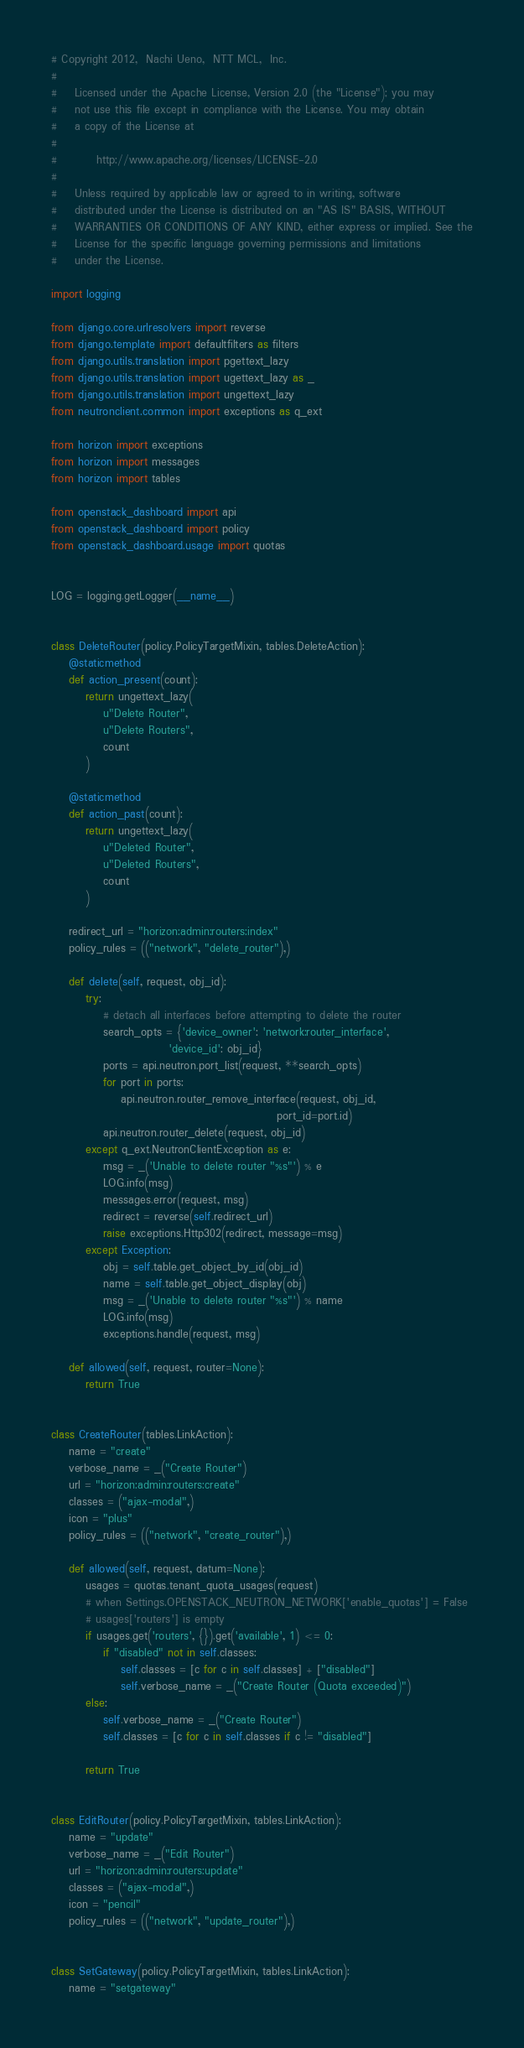<code> <loc_0><loc_0><loc_500><loc_500><_Python_># Copyright 2012,  Nachi Ueno,  NTT MCL,  Inc.
#
#    Licensed under the Apache License, Version 2.0 (the "License"); you may
#    not use this file except in compliance with the License. You may obtain
#    a copy of the License at
#
#         http://www.apache.org/licenses/LICENSE-2.0
#
#    Unless required by applicable law or agreed to in writing, software
#    distributed under the License is distributed on an "AS IS" BASIS, WITHOUT
#    WARRANTIES OR CONDITIONS OF ANY KIND, either express or implied. See the
#    License for the specific language governing permissions and limitations
#    under the License.

import logging

from django.core.urlresolvers import reverse
from django.template import defaultfilters as filters
from django.utils.translation import pgettext_lazy
from django.utils.translation import ugettext_lazy as _
from django.utils.translation import ungettext_lazy
from neutronclient.common import exceptions as q_ext

from horizon import exceptions
from horizon import messages
from horizon import tables

from openstack_dashboard import api
from openstack_dashboard import policy
from openstack_dashboard.usage import quotas


LOG = logging.getLogger(__name__)


class DeleteRouter(policy.PolicyTargetMixin, tables.DeleteAction):
    @staticmethod
    def action_present(count):
        return ungettext_lazy(
            u"Delete Router",
            u"Delete Routers",
            count
        )

    @staticmethod
    def action_past(count):
        return ungettext_lazy(
            u"Deleted Router",
            u"Deleted Routers",
            count
        )

    redirect_url = "horizon:admin:routers:index"
    policy_rules = (("network", "delete_router"),)

    def delete(self, request, obj_id):
        try:
            # detach all interfaces before attempting to delete the router
            search_opts = {'device_owner': 'network:router_interface',
                           'device_id': obj_id}
            ports = api.neutron.port_list(request, **search_opts)
            for port in ports:
                api.neutron.router_remove_interface(request, obj_id,
                                                    port_id=port.id)
            api.neutron.router_delete(request, obj_id)
        except q_ext.NeutronClientException as e:
            msg = _('Unable to delete router "%s"') % e
            LOG.info(msg)
            messages.error(request, msg)
            redirect = reverse(self.redirect_url)
            raise exceptions.Http302(redirect, message=msg)
        except Exception:
            obj = self.table.get_object_by_id(obj_id)
            name = self.table.get_object_display(obj)
            msg = _('Unable to delete router "%s"') % name
            LOG.info(msg)
            exceptions.handle(request, msg)

    def allowed(self, request, router=None):
        return True


class CreateRouter(tables.LinkAction):
    name = "create"
    verbose_name = _("Create Router")
    url = "horizon:admin:routers:create"
    classes = ("ajax-modal",)
    icon = "plus"
    policy_rules = (("network", "create_router"),)

    def allowed(self, request, datum=None):
        usages = quotas.tenant_quota_usages(request)
        # when Settings.OPENSTACK_NEUTRON_NETWORK['enable_quotas'] = False
        # usages['routers'] is empty
        if usages.get('routers', {}).get('available', 1) <= 0:
            if "disabled" not in self.classes:
                self.classes = [c for c in self.classes] + ["disabled"]
                self.verbose_name = _("Create Router (Quota exceeded)")
        else:
            self.verbose_name = _("Create Router")
            self.classes = [c for c in self.classes if c != "disabled"]

        return True


class EditRouter(policy.PolicyTargetMixin, tables.LinkAction):
    name = "update"
    verbose_name = _("Edit Router")
    url = "horizon:admin:routers:update"
    classes = ("ajax-modal",)
    icon = "pencil"
    policy_rules = (("network", "update_router"),)


class SetGateway(policy.PolicyTargetMixin, tables.LinkAction):
    name = "setgateway"</code> 